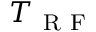<formula> <loc_0><loc_0><loc_500><loc_500>T _ { R F }</formula> 